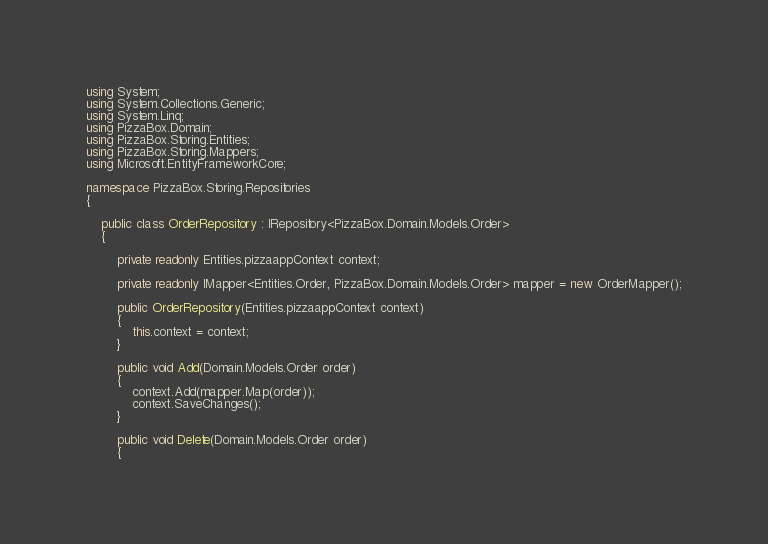<code> <loc_0><loc_0><loc_500><loc_500><_C#_>using System;
using System.Collections.Generic;
using System.Linq;
using PizzaBox.Domain;
using PizzaBox.Storing.Entities;
using PizzaBox.Storing.Mappers;
using Microsoft.EntityFrameworkCore;

namespace PizzaBox.Storing.Repositories
{

    public class OrderRepository : IRepository<PizzaBox.Domain.Models.Order>
    {

        private readonly Entities.pizzaappContext context;

        private readonly IMapper<Entities.Order, PizzaBox.Domain.Models.Order> mapper = new OrderMapper();

        public OrderRepository(Entities.pizzaappContext context)
        {
            this.context = context;
        }

        public void Add(Domain.Models.Order order)
        {
            context.Add(mapper.Map(order));
            context.SaveChanges();
        }

        public void Delete(Domain.Models.Order order)
        {</code> 